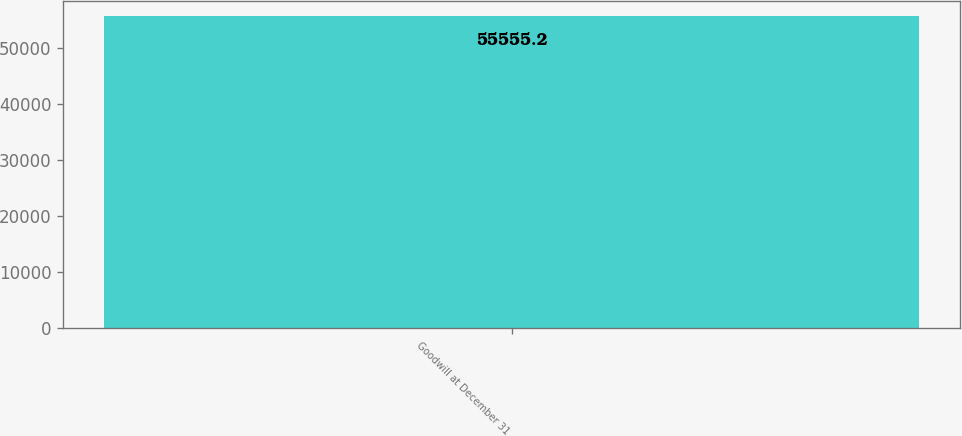Convert chart to OTSL. <chart><loc_0><loc_0><loc_500><loc_500><bar_chart><fcel>Goodwill at December 31<nl><fcel>55555.2<nl></chart> 